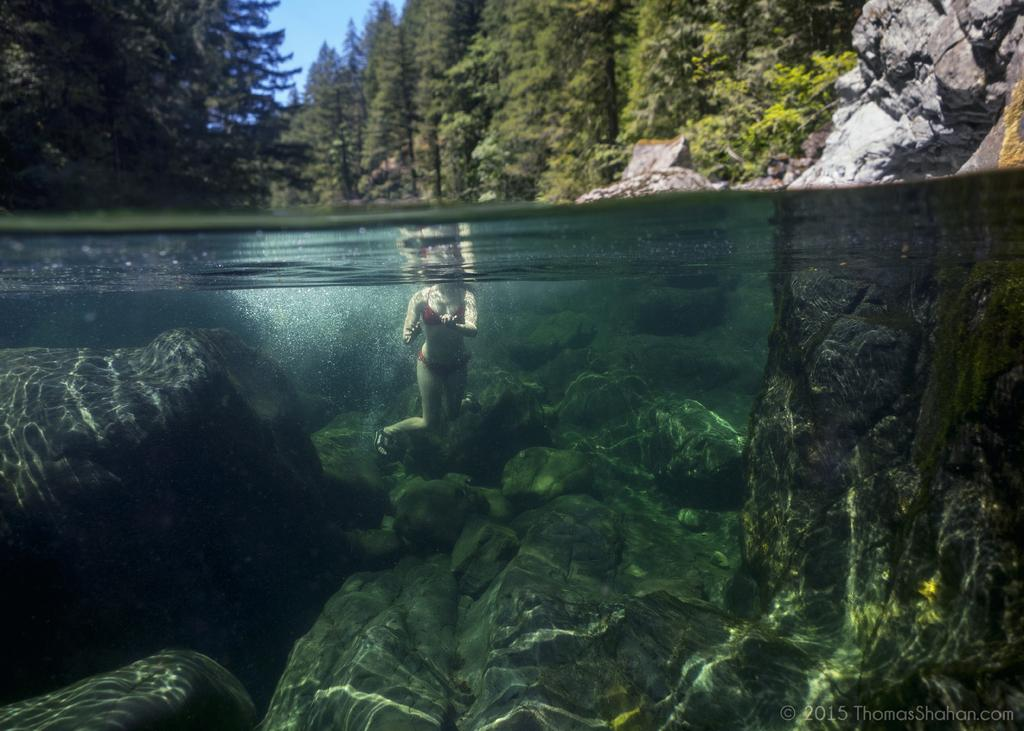What is the woman in the image doing? The woman is in the water. What can be seen in the background of the image? There are trees and rocks in the background of the image. Is there any text or logo visible in the image? Yes, there is a watermark at the right bottom of the image. What type of honey can be seen dripping from the trees in the image? There is no honey present in the image; it features a woman in the water with trees and rocks in the background. 